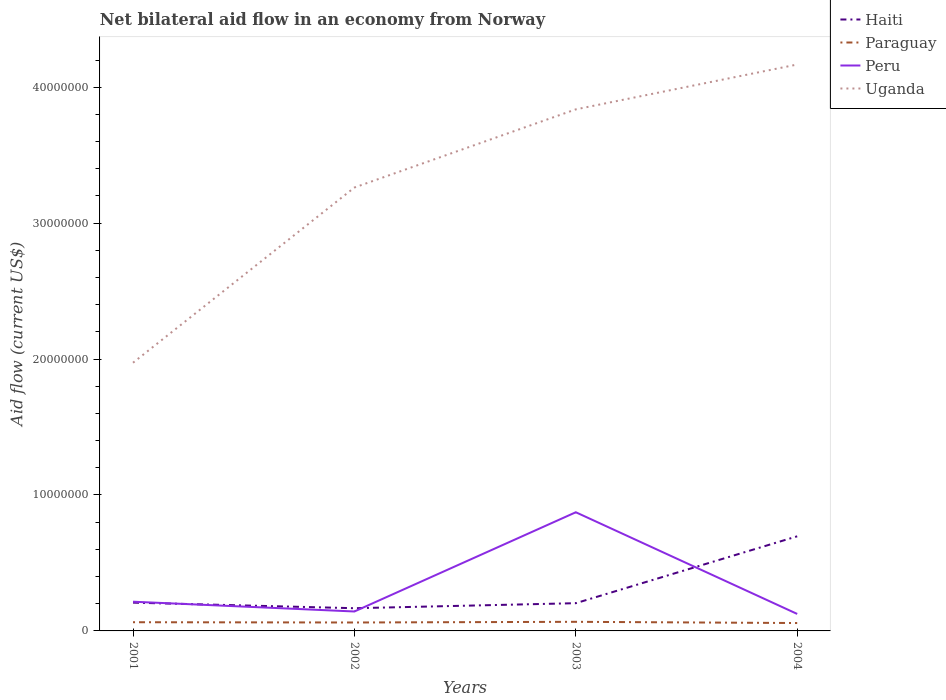Does the line corresponding to Peru intersect with the line corresponding to Uganda?
Provide a succinct answer. No. Across all years, what is the maximum net bilateral aid flow in Peru?
Offer a very short reply. 1.25e+06. In which year was the net bilateral aid flow in Peru maximum?
Your answer should be compact. 2004. What is the total net bilateral aid flow in Haiti in the graph?
Ensure brevity in your answer.  -4.92e+06. What is the difference between the highest and the second highest net bilateral aid flow in Haiti?
Ensure brevity in your answer.  5.29e+06. What is the difference between the highest and the lowest net bilateral aid flow in Peru?
Offer a terse response. 1. Is the net bilateral aid flow in Haiti strictly greater than the net bilateral aid flow in Uganda over the years?
Make the answer very short. Yes. How many lines are there?
Offer a terse response. 4. What is the difference between two consecutive major ticks on the Y-axis?
Make the answer very short. 1.00e+07. Does the graph contain any zero values?
Offer a terse response. No. What is the title of the graph?
Make the answer very short. Net bilateral aid flow in an economy from Norway. Does "Sao Tome and Principe" appear as one of the legend labels in the graph?
Provide a short and direct response. No. What is the label or title of the X-axis?
Ensure brevity in your answer.  Years. What is the label or title of the Y-axis?
Your answer should be very brief. Aid flow (current US$). What is the Aid flow (current US$) in Haiti in 2001?
Provide a succinct answer. 2.08e+06. What is the Aid flow (current US$) in Paraguay in 2001?
Your answer should be compact. 6.40e+05. What is the Aid flow (current US$) in Peru in 2001?
Keep it short and to the point. 2.15e+06. What is the Aid flow (current US$) in Uganda in 2001?
Offer a terse response. 1.97e+07. What is the Aid flow (current US$) in Haiti in 2002?
Provide a short and direct response. 1.67e+06. What is the Aid flow (current US$) in Paraguay in 2002?
Give a very brief answer. 6.20e+05. What is the Aid flow (current US$) in Peru in 2002?
Your answer should be very brief. 1.43e+06. What is the Aid flow (current US$) in Uganda in 2002?
Keep it short and to the point. 3.26e+07. What is the Aid flow (current US$) of Haiti in 2003?
Make the answer very short. 2.04e+06. What is the Aid flow (current US$) in Paraguay in 2003?
Offer a very short reply. 6.70e+05. What is the Aid flow (current US$) of Peru in 2003?
Keep it short and to the point. 8.73e+06. What is the Aid flow (current US$) of Uganda in 2003?
Make the answer very short. 3.84e+07. What is the Aid flow (current US$) in Haiti in 2004?
Give a very brief answer. 6.96e+06. What is the Aid flow (current US$) in Paraguay in 2004?
Your response must be concise. 5.80e+05. What is the Aid flow (current US$) of Peru in 2004?
Ensure brevity in your answer.  1.25e+06. What is the Aid flow (current US$) of Uganda in 2004?
Give a very brief answer. 4.17e+07. Across all years, what is the maximum Aid flow (current US$) in Haiti?
Your response must be concise. 6.96e+06. Across all years, what is the maximum Aid flow (current US$) of Paraguay?
Give a very brief answer. 6.70e+05. Across all years, what is the maximum Aid flow (current US$) of Peru?
Your response must be concise. 8.73e+06. Across all years, what is the maximum Aid flow (current US$) of Uganda?
Ensure brevity in your answer.  4.17e+07. Across all years, what is the minimum Aid flow (current US$) in Haiti?
Offer a terse response. 1.67e+06. Across all years, what is the minimum Aid flow (current US$) in Paraguay?
Offer a very short reply. 5.80e+05. Across all years, what is the minimum Aid flow (current US$) in Peru?
Your answer should be compact. 1.25e+06. Across all years, what is the minimum Aid flow (current US$) of Uganda?
Ensure brevity in your answer.  1.97e+07. What is the total Aid flow (current US$) in Haiti in the graph?
Offer a terse response. 1.28e+07. What is the total Aid flow (current US$) in Paraguay in the graph?
Provide a succinct answer. 2.51e+06. What is the total Aid flow (current US$) in Peru in the graph?
Provide a short and direct response. 1.36e+07. What is the total Aid flow (current US$) in Uganda in the graph?
Keep it short and to the point. 1.32e+08. What is the difference between the Aid flow (current US$) in Peru in 2001 and that in 2002?
Offer a terse response. 7.20e+05. What is the difference between the Aid flow (current US$) of Uganda in 2001 and that in 2002?
Provide a short and direct response. -1.29e+07. What is the difference between the Aid flow (current US$) in Haiti in 2001 and that in 2003?
Provide a short and direct response. 4.00e+04. What is the difference between the Aid flow (current US$) of Paraguay in 2001 and that in 2003?
Offer a very short reply. -3.00e+04. What is the difference between the Aid flow (current US$) in Peru in 2001 and that in 2003?
Keep it short and to the point. -6.58e+06. What is the difference between the Aid flow (current US$) in Uganda in 2001 and that in 2003?
Your answer should be very brief. -1.86e+07. What is the difference between the Aid flow (current US$) of Haiti in 2001 and that in 2004?
Your answer should be compact. -4.88e+06. What is the difference between the Aid flow (current US$) of Peru in 2001 and that in 2004?
Provide a short and direct response. 9.00e+05. What is the difference between the Aid flow (current US$) in Uganda in 2001 and that in 2004?
Provide a short and direct response. -2.19e+07. What is the difference between the Aid flow (current US$) in Haiti in 2002 and that in 2003?
Your response must be concise. -3.70e+05. What is the difference between the Aid flow (current US$) in Peru in 2002 and that in 2003?
Provide a succinct answer. -7.30e+06. What is the difference between the Aid flow (current US$) of Uganda in 2002 and that in 2003?
Give a very brief answer. -5.75e+06. What is the difference between the Aid flow (current US$) of Haiti in 2002 and that in 2004?
Your answer should be compact. -5.29e+06. What is the difference between the Aid flow (current US$) in Paraguay in 2002 and that in 2004?
Your answer should be very brief. 4.00e+04. What is the difference between the Aid flow (current US$) in Peru in 2002 and that in 2004?
Your answer should be compact. 1.80e+05. What is the difference between the Aid flow (current US$) of Uganda in 2002 and that in 2004?
Your answer should be very brief. -9.05e+06. What is the difference between the Aid flow (current US$) of Haiti in 2003 and that in 2004?
Provide a succinct answer. -4.92e+06. What is the difference between the Aid flow (current US$) of Peru in 2003 and that in 2004?
Give a very brief answer. 7.48e+06. What is the difference between the Aid flow (current US$) of Uganda in 2003 and that in 2004?
Offer a very short reply. -3.30e+06. What is the difference between the Aid flow (current US$) of Haiti in 2001 and the Aid flow (current US$) of Paraguay in 2002?
Ensure brevity in your answer.  1.46e+06. What is the difference between the Aid flow (current US$) in Haiti in 2001 and the Aid flow (current US$) in Peru in 2002?
Provide a short and direct response. 6.50e+05. What is the difference between the Aid flow (current US$) of Haiti in 2001 and the Aid flow (current US$) of Uganda in 2002?
Provide a short and direct response. -3.05e+07. What is the difference between the Aid flow (current US$) in Paraguay in 2001 and the Aid flow (current US$) in Peru in 2002?
Your answer should be compact. -7.90e+05. What is the difference between the Aid flow (current US$) in Paraguay in 2001 and the Aid flow (current US$) in Uganda in 2002?
Make the answer very short. -3.20e+07. What is the difference between the Aid flow (current US$) in Peru in 2001 and the Aid flow (current US$) in Uganda in 2002?
Offer a terse response. -3.05e+07. What is the difference between the Aid flow (current US$) in Haiti in 2001 and the Aid flow (current US$) in Paraguay in 2003?
Offer a very short reply. 1.41e+06. What is the difference between the Aid flow (current US$) of Haiti in 2001 and the Aid flow (current US$) of Peru in 2003?
Provide a short and direct response. -6.65e+06. What is the difference between the Aid flow (current US$) in Haiti in 2001 and the Aid flow (current US$) in Uganda in 2003?
Your response must be concise. -3.63e+07. What is the difference between the Aid flow (current US$) of Paraguay in 2001 and the Aid flow (current US$) of Peru in 2003?
Keep it short and to the point. -8.09e+06. What is the difference between the Aid flow (current US$) of Paraguay in 2001 and the Aid flow (current US$) of Uganda in 2003?
Your answer should be very brief. -3.77e+07. What is the difference between the Aid flow (current US$) of Peru in 2001 and the Aid flow (current US$) of Uganda in 2003?
Your answer should be compact. -3.62e+07. What is the difference between the Aid flow (current US$) in Haiti in 2001 and the Aid flow (current US$) in Paraguay in 2004?
Your response must be concise. 1.50e+06. What is the difference between the Aid flow (current US$) of Haiti in 2001 and the Aid flow (current US$) of Peru in 2004?
Give a very brief answer. 8.30e+05. What is the difference between the Aid flow (current US$) in Haiti in 2001 and the Aid flow (current US$) in Uganda in 2004?
Keep it short and to the point. -3.96e+07. What is the difference between the Aid flow (current US$) in Paraguay in 2001 and the Aid flow (current US$) in Peru in 2004?
Your answer should be compact. -6.10e+05. What is the difference between the Aid flow (current US$) of Paraguay in 2001 and the Aid flow (current US$) of Uganda in 2004?
Keep it short and to the point. -4.10e+07. What is the difference between the Aid flow (current US$) of Peru in 2001 and the Aid flow (current US$) of Uganda in 2004?
Your answer should be compact. -3.95e+07. What is the difference between the Aid flow (current US$) in Haiti in 2002 and the Aid flow (current US$) in Paraguay in 2003?
Your response must be concise. 1.00e+06. What is the difference between the Aid flow (current US$) of Haiti in 2002 and the Aid flow (current US$) of Peru in 2003?
Your answer should be very brief. -7.06e+06. What is the difference between the Aid flow (current US$) of Haiti in 2002 and the Aid flow (current US$) of Uganda in 2003?
Keep it short and to the point. -3.67e+07. What is the difference between the Aid flow (current US$) of Paraguay in 2002 and the Aid flow (current US$) of Peru in 2003?
Your answer should be compact. -8.11e+06. What is the difference between the Aid flow (current US$) in Paraguay in 2002 and the Aid flow (current US$) in Uganda in 2003?
Provide a succinct answer. -3.78e+07. What is the difference between the Aid flow (current US$) of Peru in 2002 and the Aid flow (current US$) of Uganda in 2003?
Your answer should be very brief. -3.69e+07. What is the difference between the Aid flow (current US$) in Haiti in 2002 and the Aid flow (current US$) in Paraguay in 2004?
Provide a succinct answer. 1.09e+06. What is the difference between the Aid flow (current US$) in Haiti in 2002 and the Aid flow (current US$) in Uganda in 2004?
Provide a succinct answer. -4.00e+07. What is the difference between the Aid flow (current US$) of Paraguay in 2002 and the Aid flow (current US$) of Peru in 2004?
Make the answer very short. -6.30e+05. What is the difference between the Aid flow (current US$) in Paraguay in 2002 and the Aid flow (current US$) in Uganda in 2004?
Your answer should be compact. -4.10e+07. What is the difference between the Aid flow (current US$) of Peru in 2002 and the Aid flow (current US$) of Uganda in 2004?
Offer a very short reply. -4.02e+07. What is the difference between the Aid flow (current US$) of Haiti in 2003 and the Aid flow (current US$) of Paraguay in 2004?
Provide a succinct answer. 1.46e+06. What is the difference between the Aid flow (current US$) of Haiti in 2003 and the Aid flow (current US$) of Peru in 2004?
Your answer should be very brief. 7.90e+05. What is the difference between the Aid flow (current US$) in Haiti in 2003 and the Aid flow (current US$) in Uganda in 2004?
Give a very brief answer. -3.96e+07. What is the difference between the Aid flow (current US$) in Paraguay in 2003 and the Aid flow (current US$) in Peru in 2004?
Your response must be concise. -5.80e+05. What is the difference between the Aid flow (current US$) in Paraguay in 2003 and the Aid flow (current US$) in Uganda in 2004?
Your response must be concise. -4.10e+07. What is the difference between the Aid flow (current US$) of Peru in 2003 and the Aid flow (current US$) of Uganda in 2004?
Ensure brevity in your answer.  -3.29e+07. What is the average Aid flow (current US$) in Haiti per year?
Ensure brevity in your answer.  3.19e+06. What is the average Aid flow (current US$) in Paraguay per year?
Your answer should be compact. 6.28e+05. What is the average Aid flow (current US$) of Peru per year?
Offer a terse response. 3.39e+06. What is the average Aid flow (current US$) of Uganda per year?
Keep it short and to the point. 3.31e+07. In the year 2001, what is the difference between the Aid flow (current US$) of Haiti and Aid flow (current US$) of Paraguay?
Offer a very short reply. 1.44e+06. In the year 2001, what is the difference between the Aid flow (current US$) in Haiti and Aid flow (current US$) in Peru?
Offer a terse response. -7.00e+04. In the year 2001, what is the difference between the Aid flow (current US$) of Haiti and Aid flow (current US$) of Uganda?
Provide a succinct answer. -1.76e+07. In the year 2001, what is the difference between the Aid flow (current US$) in Paraguay and Aid flow (current US$) in Peru?
Provide a succinct answer. -1.51e+06. In the year 2001, what is the difference between the Aid flow (current US$) in Paraguay and Aid flow (current US$) in Uganda?
Provide a succinct answer. -1.91e+07. In the year 2001, what is the difference between the Aid flow (current US$) of Peru and Aid flow (current US$) of Uganda?
Provide a succinct answer. -1.76e+07. In the year 2002, what is the difference between the Aid flow (current US$) in Haiti and Aid flow (current US$) in Paraguay?
Your answer should be very brief. 1.05e+06. In the year 2002, what is the difference between the Aid flow (current US$) of Haiti and Aid flow (current US$) of Peru?
Your answer should be compact. 2.40e+05. In the year 2002, what is the difference between the Aid flow (current US$) in Haiti and Aid flow (current US$) in Uganda?
Provide a short and direct response. -3.10e+07. In the year 2002, what is the difference between the Aid flow (current US$) in Paraguay and Aid flow (current US$) in Peru?
Your answer should be compact. -8.10e+05. In the year 2002, what is the difference between the Aid flow (current US$) in Paraguay and Aid flow (current US$) in Uganda?
Your answer should be very brief. -3.20e+07. In the year 2002, what is the difference between the Aid flow (current US$) in Peru and Aid flow (current US$) in Uganda?
Keep it short and to the point. -3.12e+07. In the year 2003, what is the difference between the Aid flow (current US$) in Haiti and Aid flow (current US$) in Paraguay?
Your answer should be compact. 1.37e+06. In the year 2003, what is the difference between the Aid flow (current US$) in Haiti and Aid flow (current US$) in Peru?
Provide a succinct answer. -6.69e+06. In the year 2003, what is the difference between the Aid flow (current US$) of Haiti and Aid flow (current US$) of Uganda?
Offer a terse response. -3.63e+07. In the year 2003, what is the difference between the Aid flow (current US$) in Paraguay and Aid flow (current US$) in Peru?
Offer a very short reply. -8.06e+06. In the year 2003, what is the difference between the Aid flow (current US$) of Paraguay and Aid flow (current US$) of Uganda?
Make the answer very short. -3.77e+07. In the year 2003, what is the difference between the Aid flow (current US$) of Peru and Aid flow (current US$) of Uganda?
Give a very brief answer. -2.96e+07. In the year 2004, what is the difference between the Aid flow (current US$) in Haiti and Aid flow (current US$) in Paraguay?
Offer a very short reply. 6.38e+06. In the year 2004, what is the difference between the Aid flow (current US$) of Haiti and Aid flow (current US$) of Peru?
Make the answer very short. 5.71e+06. In the year 2004, what is the difference between the Aid flow (current US$) of Haiti and Aid flow (current US$) of Uganda?
Ensure brevity in your answer.  -3.47e+07. In the year 2004, what is the difference between the Aid flow (current US$) in Paraguay and Aid flow (current US$) in Peru?
Keep it short and to the point. -6.70e+05. In the year 2004, what is the difference between the Aid flow (current US$) in Paraguay and Aid flow (current US$) in Uganda?
Provide a short and direct response. -4.11e+07. In the year 2004, what is the difference between the Aid flow (current US$) of Peru and Aid flow (current US$) of Uganda?
Your answer should be very brief. -4.04e+07. What is the ratio of the Aid flow (current US$) of Haiti in 2001 to that in 2002?
Your answer should be compact. 1.25. What is the ratio of the Aid flow (current US$) in Paraguay in 2001 to that in 2002?
Offer a terse response. 1.03. What is the ratio of the Aid flow (current US$) of Peru in 2001 to that in 2002?
Offer a very short reply. 1.5. What is the ratio of the Aid flow (current US$) of Uganda in 2001 to that in 2002?
Provide a succinct answer. 0.6. What is the ratio of the Aid flow (current US$) in Haiti in 2001 to that in 2003?
Your answer should be compact. 1.02. What is the ratio of the Aid flow (current US$) in Paraguay in 2001 to that in 2003?
Provide a succinct answer. 0.96. What is the ratio of the Aid flow (current US$) of Peru in 2001 to that in 2003?
Your response must be concise. 0.25. What is the ratio of the Aid flow (current US$) of Uganda in 2001 to that in 2003?
Your answer should be compact. 0.51. What is the ratio of the Aid flow (current US$) in Haiti in 2001 to that in 2004?
Make the answer very short. 0.3. What is the ratio of the Aid flow (current US$) in Paraguay in 2001 to that in 2004?
Make the answer very short. 1.1. What is the ratio of the Aid flow (current US$) of Peru in 2001 to that in 2004?
Your response must be concise. 1.72. What is the ratio of the Aid flow (current US$) of Uganda in 2001 to that in 2004?
Keep it short and to the point. 0.47. What is the ratio of the Aid flow (current US$) of Haiti in 2002 to that in 2003?
Provide a short and direct response. 0.82. What is the ratio of the Aid flow (current US$) in Paraguay in 2002 to that in 2003?
Provide a short and direct response. 0.93. What is the ratio of the Aid flow (current US$) of Peru in 2002 to that in 2003?
Provide a short and direct response. 0.16. What is the ratio of the Aid flow (current US$) in Uganda in 2002 to that in 2003?
Your answer should be very brief. 0.85. What is the ratio of the Aid flow (current US$) in Haiti in 2002 to that in 2004?
Ensure brevity in your answer.  0.24. What is the ratio of the Aid flow (current US$) in Paraguay in 2002 to that in 2004?
Your answer should be compact. 1.07. What is the ratio of the Aid flow (current US$) in Peru in 2002 to that in 2004?
Give a very brief answer. 1.14. What is the ratio of the Aid flow (current US$) in Uganda in 2002 to that in 2004?
Give a very brief answer. 0.78. What is the ratio of the Aid flow (current US$) in Haiti in 2003 to that in 2004?
Give a very brief answer. 0.29. What is the ratio of the Aid flow (current US$) of Paraguay in 2003 to that in 2004?
Offer a very short reply. 1.16. What is the ratio of the Aid flow (current US$) in Peru in 2003 to that in 2004?
Your answer should be compact. 6.98. What is the ratio of the Aid flow (current US$) of Uganda in 2003 to that in 2004?
Make the answer very short. 0.92. What is the difference between the highest and the second highest Aid flow (current US$) in Haiti?
Offer a terse response. 4.88e+06. What is the difference between the highest and the second highest Aid flow (current US$) of Paraguay?
Give a very brief answer. 3.00e+04. What is the difference between the highest and the second highest Aid flow (current US$) of Peru?
Make the answer very short. 6.58e+06. What is the difference between the highest and the second highest Aid flow (current US$) of Uganda?
Offer a terse response. 3.30e+06. What is the difference between the highest and the lowest Aid flow (current US$) in Haiti?
Your response must be concise. 5.29e+06. What is the difference between the highest and the lowest Aid flow (current US$) in Paraguay?
Offer a terse response. 9.00e+04. What is the difference between the highest and the lowest Aid flow (current US$) of Peru?
Keep it short and to the point. 7.48e+06. What is the difference between the highest and the lowest Aid flow (current US$) of Uganda?
Provide a short and direct response. 2.19e+07. 